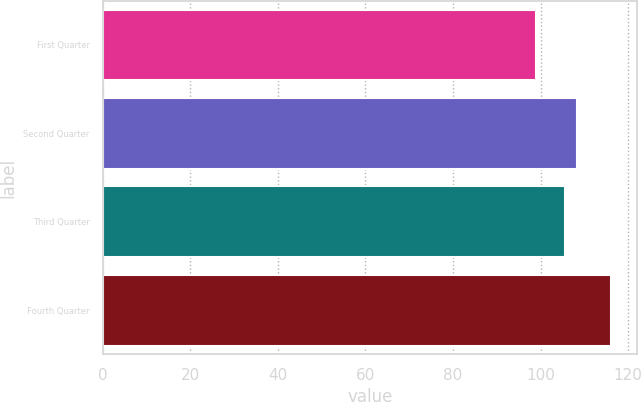<chart> <loc_0><loc_0><loc_500><loc_500><bar_chart><fcel>First Quarter<fcel>Second Quarter<fcel>Third Quarter<fcel>Fourth Quarter<nl><fcel>98.95<fcel>108.33<fcel>105.68<fcel>116.14<nl></chart> 